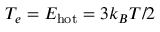Convert formula to latex. <formula><loc_0><loc_0><loc_500><loc_500>T _ { e } = E _ { h o t } = 3 k _ { B } T / 2</formula> 